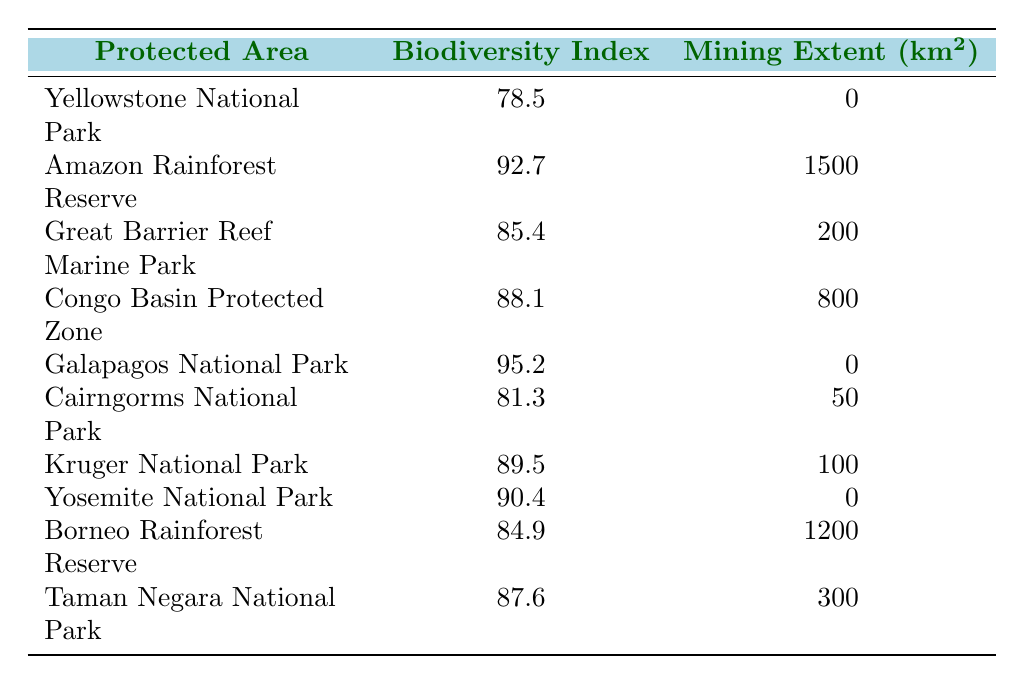What is the biodiversity index of Galapagos National Park? The table specifies the biodiversity index for Galapagos National Park as 95.2.
Answer: 95.2 How many protected areas have a mining extent of 0 km²? By reviewing the table, I can see that there are 4 protected areas with a mining extent of 0 km²: Yellowstone National Park, Galapagos National Park, and Yosemite National Park.
Answer: 3 What is the average biodiversity index of the protected areas where mining is present? First, identify all protected areas with mining extents: Amazon Rainforest Reserve, Great Barrier Reef Marine Park, Congo Basin Protected Zone, Cairngorms National Park, Kruger National Park, Borneo Rainforest Reserve, and Taman Negara National Park (7 in total). The biodiversity indices for these areas are 92.7, 85.4, 88.1, 81.3, 89.5, 84.9, and 87.6. To find the average, sum these indices: (92.7 + 85.4 + 88.1 + 81.3 + 89.5 + 84.9 + 87.6) = 509.5. Then divide by the number of areas: 509.5 / 7 = 72.8.
Answer: 72.8 Is the biodiversity index of the Amazon Rainforest Reserve greater than 90? The table lists the biodiversity index of the Amazon Rainforest Reserve as 92.7, which is indeed greater than 90.
Answer: Yes Which protected area has the highest mining extent and what is its biodiversity index? Borneo Rainforest Reserve has the highest mining extent at 1200 km². Its biodiversity index is 84.9.
Answer: Borneo Rainforest Reserve, 84.9 